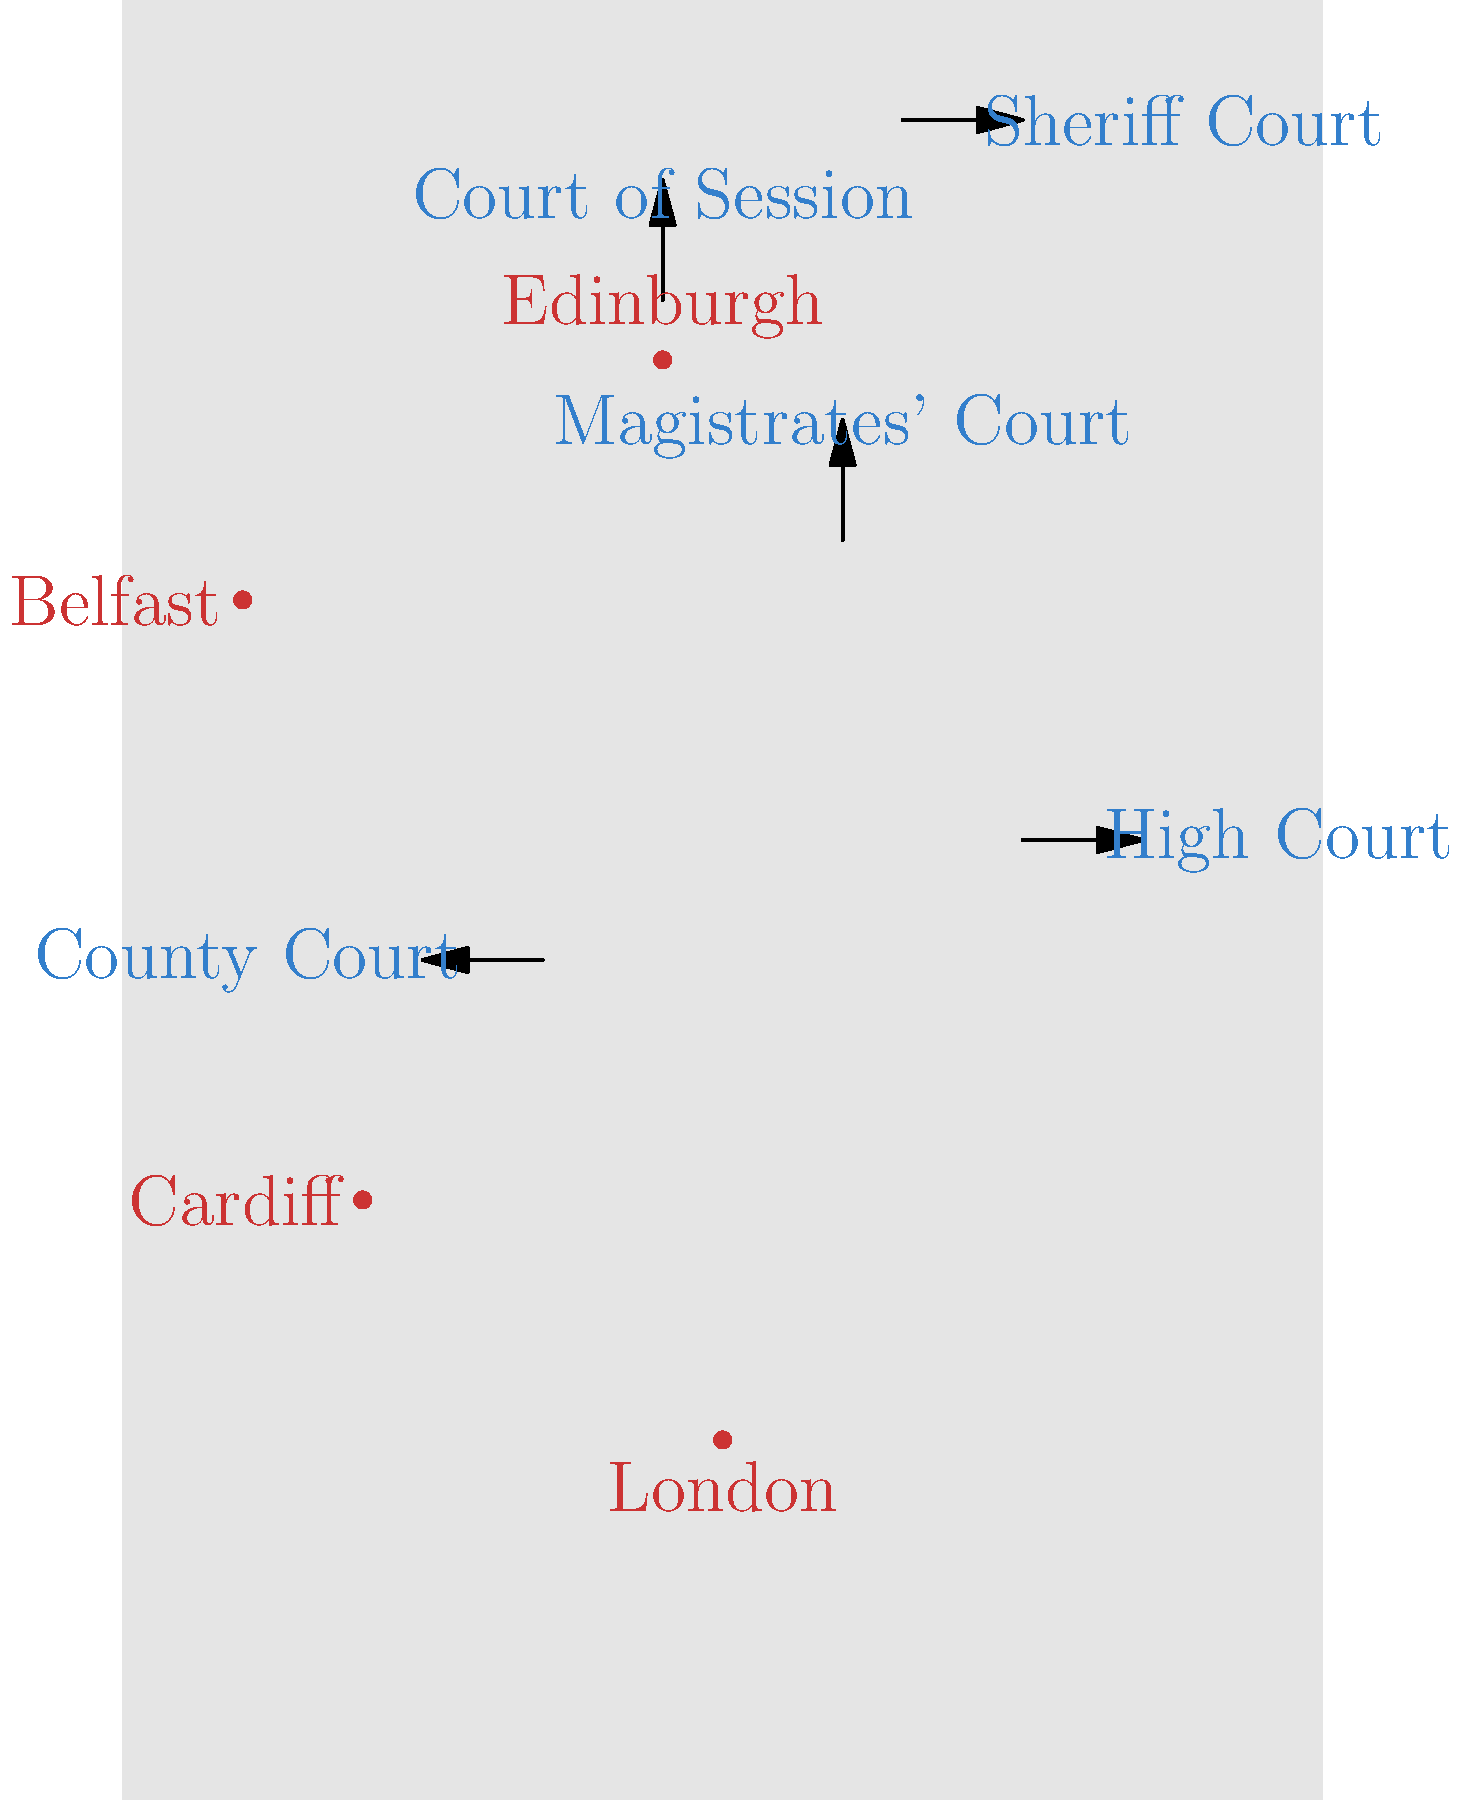Based on the map of the UK court system in the 19th century, which type of court was most prevalent in Scotland and how did it differ from its English counterpart? To answer this question, we need to analyze the map and understand the historical context of the UK court system in the 19th century:

1. The map shows different types of courts across the UK, including High Court, County Court, Magistrates' Court, Court of Session, and Sheriff Court.

2. Scotland is represented in the northern part of the map, with Edinburgh as its major city.

3. Near Edinburgh, we can see two types of courts: the Court of Session and the Sheriff Court.

4. The Sheriff Court is shown to be more widespread in Scotland, as indicated by its position on the map.

5. In England, the County Courts were established in 1846 to handle civil cases, similar to the role of Sheriff Courts in Scotland.

6. The main difference between Sheriff Courts and County Courts was their historical origin and jurisdiction:
   - Sheriff Courts in Scotland date back to the 12th century and had both civil and criminal jurisdiction.
   - County Courts in England were relatively new (19th century) and primarily handled civil cases.

7. The Sheriff Courts in Scotland were presided over by Sheriffs, who were legally qualified judges, whereas English County Courts were presided over by County Court judges.

8. Sheriff Courts had a broader jurisdiction, including some criminal cases, while County Courts were limited to civil matters.

Therefore, the Sheriff Court was the most prevalent type of court in Scotland during the 19th century, differing from its English counterpart (the County Court) in terms of historical origin, jurisdiction, and the qualifications of its presiding judges.
Answer: Sheriff Court; broader jurisdiction and longer history than English County Courts 